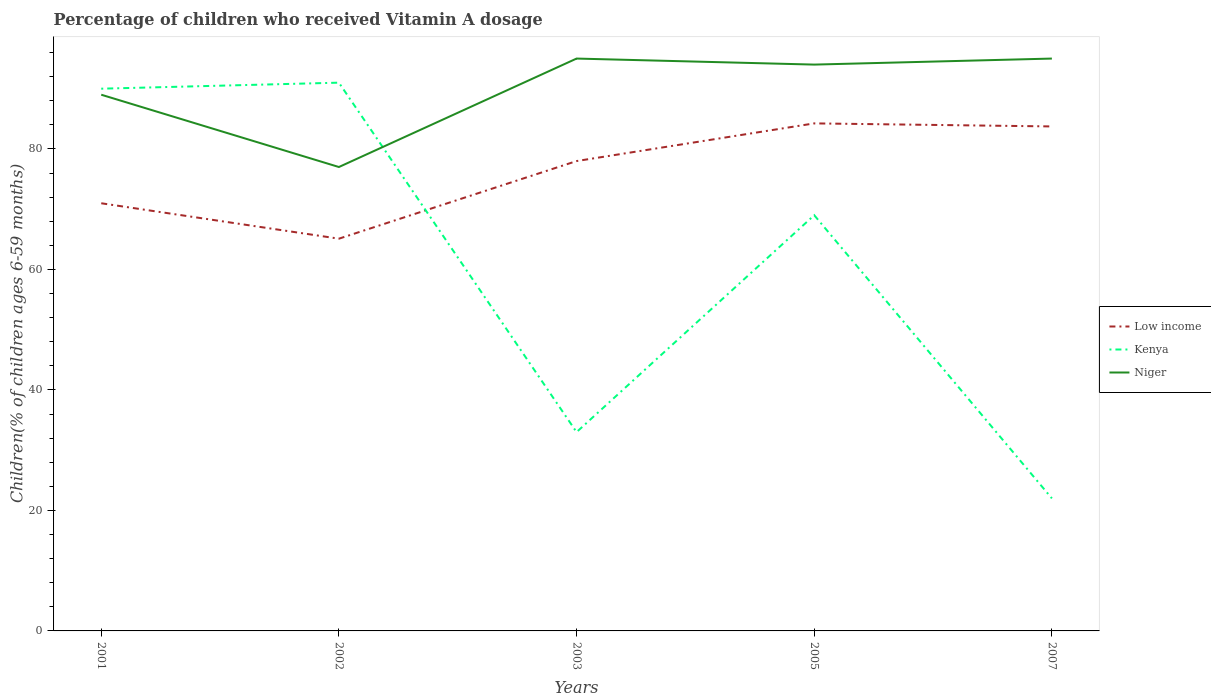Across all years, what is the maximum percentage of children who received Vitamin A dosage in Kenya?
Keep it short and to the point. 22. What is the total percentage of children who received Vitamin A dosage in Niger in the graph?
Your response must be concise. -1. What is the difference between the highest and the second highest percentage of children who received Vitamin A dosage in Niger?
Your answer should be compact. 18. Is the percentage of children who received Vitamin A dosage in Kenya strictly greater than the percentage of children who received Vitamin A dosage in Low income over the years?
Make the answer very short. No. What is the difference between two consecutive major ticks on the Y-axis?
Keep it short and to the point. 20. Does the graph contain any zero values?
Your answer should be very brief. No. Where does the legend appear in the graph?
Your answer should be compact. Center right. How many legend labels are there?
Provide a succinct answer. 3. What is the title of the graph?
Your answer should be compact. Percentage of children who received Vitamin A dosage. What is the label or title of the Y-axis?
Offer a terse response. Children(% of children ages 6-59 months). What is the Children(% of children ages 6-59 months) of Low income in 2001?
Provide a succinct answer. 70.98. What is the Children(% of children ages 6-59 months) of Niger in 2001?
Keep it short and to the point. 89. What is the Children(% of children ages 6-59 months) of Low income in 2002?
Give a very brief answer. 65.1. What is the Children(% of children ages 6-59 months) in Kenya in 2002?
Your answer should be very brief. 91. What is the Children(% of children ages 6-59 months) in Niger in 2002?
Provide a short and direct response. 77. What is the Children(% of children ages 6-59 months) of Low income in 2003?
Provide a succinct answer. 77.99. What is the Children(% of children ages 6-59 months) of Kenya in 2003?
Your response must be concise. 33. What is the Children(% of children ages 6-59 months) in Niger in 2003?
Make the answer very short. 95. What is the Children(% of children ages 6-59 months) in Low income in 2005?
Make the answer very short. 84.24. What is the Children(% of children ages 6-59 months) of Kenya in 2005?
Make the answer very short. 69. What is the Children(% of children ages 6-59 months) of Niger in 2005?
Keep it short and to the point. 94. What is the Children(% of children ages 6-59 months) of Low income in 2007?
Your answer should be compact. 83.73. What is the Children(% of children ages 6-59 months) in Kenya in 2007?
Make the answer very short. 22. What is the Children(% of children ages 6-59 months) of Niger in 2007?
Your response must be concise. 95. Across all years, what is the maximum Children(% of children ages 6-59 months) in Low income?
Provide a succinct answer. 84.24. Across all years, what is the maximum Children(% of children ages 6-59 months) in Kenya?
Your response must be concise. 91. Across all years, what is the maximum Children(% of children ages 6-59 months) in Niger?
Offer a very short reply. 95. Across all years, what is the minimum Children(% of children ages 6-59 months) in Low income?
Your answer should be very brief. 65.1. Across all years, what is the minimum Children(% of children ages 6-59 months) in Kenya?
Keep it short and to the point. 22. What is the total Children(% of children ages 6-59 months) of Low income in the graph?
Your answer should be compact. 382.05. What is the total Children(% of children ages 6-59 months) in Kenya in the graph?
Ensure brevity in your answer.  305. What is the total Children(% of children ages 6-59 months) in Niger in the graph?
Make the answer very short. 450. What is the difference between the Children(% of children ages 6-59 months) of Low income in 2001 and that in 2002?
Offer a very short reply. 5.88. What is the difference between the Children(% of children ages 6-59 months) in Kenya in 2001 and that in 2002?
Provide a short and direct response. -1. What is the difference between the Children(% of children ages 6-59 months) in Low income in 2001 and that in 2003?
Keep it short and to the point. -7. What is the difference between the Children(% of children ages 6-59 months) in Low income in 2001 and that in 2005?
Your answer should be compact. -13.26. What is the difference between the Children(% of children ages 6-59 months) of Niger in 2001 and that in 2005?
Offer a terse response. -5. What is the difference between the Children(% of children ages 6-59 months) of Low income in 2001 and that in 2007?
Offer a very short reply. -12.75. What is the difference between the Children(% of children ages 6-59 months) of Low income in 2002 and that in 2003?
Keep it short and to the point. -12.88. What is the difference between the Children(% of children ages 6-59 months) of Kenya in 2002 and that in 2003?
Offer a very short reply. 58. What is the difference between the Children(% of children ages 6-59 months) of Low income in 2002 and that in 2005?
Ensure brevity in your answer.  -19.14. What is the difference between the Children(% of children ages 6-59 months) of Kenya in 2002 and that in 2005?
Your answer should be compact. 22. What is the difference between the Children(% of children ages 6-59 months) of Niger in 2002 and that in 2005?
Ensure brevity in your answer.  -17. What is the difference between the Children(% of children ages 6-59 months) of Low income in 2002 and that in 2007?
Make the answer very short. -18.63. What is the difference between the Children(% of children ages 6-59 months) of Kenya in 2002 and that in 2007?
Keep it short and to the point. 69. What is the difference between the Children(% of children ages 6-59 months) of Niger in 2002 and that in 2007?
Give a very brief answer. -18. What is the difference between the Children(% of children ages 6-59 months) in Low income in 2003 and that in 2005?
Keep it short and to the point. -6.25. What is the difference between the Children(% of children ages 6-59 months) in Kenya in 2003 and that in 2005?
Provide a short and direct response. -36. What is the difference between the Children(% of children ages 6-59 months) of Low income in 2003 and that in 2007?
Your answer should be compact. -5.75. What is the difference between the Children(% of children ages 6-59 months) of Niger in 2003 and that in 2007?
Make the answer very short. 0. What is the difference between the Children(% of children ages 6-59 months) of Low income in 2005 and that in 2007?
Give a very brief answer. 0.51. What is the difference between the Children(% of children ages 6-59 months) in Kenya in 2005 and that in 2007?
Provide a short and direct response. 47. What is the difference between the Children(% of children ages 6-59 months) of Low income in 2001 and the Children(% of children ages 6-59 months) of Kenya in 2002?
Offer a terse response. -20.02. What is the difference between the Children(% of children ages 6-59 months) of Low income in 2001 and the Children(% of children ages 6-59 months) of Niger in 2002?
Offer a terse response. -6.02. What is the difference between the Children(% of children ages 6-59 months) in Low income in 2001 and the Children(% of children ages 6-59 months) in Kenya in 2003?
Your response must be concise. 37.98. What is the difference between the Children(% of children ages 6-59 months) in Low income in 2001 and the Children(% of children ages 6-59 months) in Niger in 2003?
Your response must be concise. -24.02. What is the difference between the Children(% of children ages 6-59 months) of Kenya in 2001 and the Children(% of children ages 6-59 months) of Niger in 2003?
Offer a very short reply. -5. What is the difference between the Children(% of children ages 6-59 months) of Low income in 2001 and the Children(% of children ages 6-59 months) of Kenya in 2005?
Offer a very short reply. 1.98. What is the difference between the Children(% of children ages 6-59 months) in Low income in 2001 and the Children(% of children ages 6-59 months) in Niger in 2005?
Offer a very short reply. -23.02. What is the difference between the Children(% of children ages 6-59 months) of Kenya in 2001 and the Children(% of children ages 6-59 months) of Niger in 2005?
Make the answer very short. -4. What is the difference between the Children(% of children ages 6-59 months) in Low income in 2001 and the Children(% of children ages 6-59 months) in Kenya in 2007?
Provide a succinct answer. 48.98. What is the difference between the Children(% of children ages 6-59 months) in Low income in 2001 and the Children(% of children ages 6-59 months) in Niger in 2007?
Offer a terse response. -24.02. What is the difference between the Children(% of children ages 6-59 months) in Kenya in 2001 and the Children(% of children ages 6-59 months) in Niger in 2007?
Make the answer very short. -5. What is the difference between the Children(% of children ages 6-59 months) of Low income in 2002 and the Children(% of children ages 6-59 months) of Kenya in 2003?
Your answer should be compact. 32.1. What is the difference between the Children(% of children ages 6-59 months) of Low income in 2002 and the Children(% of children ages 6-59 months) of Niger in 2003?
Offer a terse response. -29.9. What is the difference between the Children(% of children ages 6-59 months) in Kenya in 2002 and the Children(% of children ages 6-59 months) in Niger in 2003?
Offer a very short reply. -4. What is the difference between the Children(% of children ages 6-59 months) of Low income in 2002 and the Children(% of children ages 6-59 months) of Kenya in 2005?
Your answer should be compact. -3.9. What is the difference between the Children(% of children ages 6-59 months) of Low income in 2002 and the Children(% of children ages 6-59 months) of Niger in 2005?
Your response must be concise. -28.9. What is the difference between the Children(% of children ages 6-59 months) of Low income in 2002 and the Children(% of children ages 6-59 months) of Kenya in 2007?
Provide a succinct answer. 43.1. What is the difference between the Children(% of children ages 6-59 months) of Low income in 2002 and the Children(% of children ages 6-59 months) of Niger in 2007?
Provide a short and direct response. -29.9. What is the difference between the Children(% of children ages 6-59 months) in Kenya in 2002 and the Children(% of children ages 6-59 months) in Niger in 2007?
Make the answer very short. -4. What is the difference between the Children(% of children ages 6-59 months) of Low income in 2003 and the Children(% of children ages 6-59 months) of Kenya in 2005?
Offer a very short reply. 8.99. What is the difference between the Children(% of children ages 6-59 months) in Low income in 2003 and the Children(% of children ages 6-59 months) in Niger in 2005?
Make the answer very short. -16.01. What is the difference between the Children(% of children ages 6-59 months) of Kenya in 2003 and the Children(% of children ages 6-59 months) of Niger in 2005?
Provide a short and direct response. -61. What is the difference between the Children(% of children ages 6-59 months) in Low income in 2003 and the Children(% of children ages 6-59 months) in Kenya in 2007?
Make the answer very short. 55.99. What is the difference between the Children(% of children ages 6-59 months) of Low income in 2003 and the Children(% of children ages 6-59 months) of Niger in 2007?
Ensure brevity in your answer.  -17.01. What is the difference between the Children(% of children ages 6-59 months) of Kenya in 2003 and the Children(% of children ages 6-59 months) of Niger in 2007?
Provide a succinct answer. -62. What is the difference between the Children(% of children ages 6-59 months) in Low income in 2005 and the Children(% of children ages 6-59 months) in Kenya in 2007?
Your answer should be compact. 62.24. What is the difference between the Children(% of children ages 6-59 months) in Low income in 2005 and the Children(% of children ages 6-59 months) in Niger in 2007?
Ensure brevity in your answer.  -10.76. What is the difference between the Children(% of children ages 6-59 months) of Kenya in 2005 and the Children(% of children ages 6-59 months) of Niger in 2007?
Offer a very short reply. -26. What is the average Children(% of children ages 6-59 months) in Low income per year?
Offer a very short reply. 76.41. What is the average Children(% of children ages 6-59 months) of Kenya per year?
Offer a very short reply. 61. In the year 2001, what is the difference between the Children(% of children ages 6-59 months) of Low income and Children(% of children ages 6-59 months) of Kenya?
Your answer should be compact. -19.02. In the year 2001, what is the difference between the Children(% of children ages 6-59 months) in Low income and Children(% of children ages 6-59 months) in Niger?
Offer a terse response. -18.02. In the year 2002, what is the difference between the Children(% of children ages 6-59 months) in Low income and Children(% of children ages 6-59 months) in Kenya?
Ensure brevity in your answer.  -25.9. In the year 2002, what is the difference between the Children(% of children ages 6-59 months) of Low income and Children(% of children ages 6-59 months) of Niger?
Your answer should be compact. -11.9. In the year 2002, what is the difference between the Children(% of children ages 6-59 months) of Kenya and Children(% of children ages 6-59 months) of Niger?
Your response must be concise. 14. In the year 2003, what is the difference between the Children(% of children ages 6-59 months) in Low income and Children(% of children ages 6-59 months) in Kenya?
Keep it short and to the point. 44.99. In the year 2003, what is the difference between the Children(% of children ages 6-59 months) in Low income and Children(% of children ages 6-59 months) in Niger?
Offer a very short reply. -17.01. In the year 2003, what is the difference between the Children(% of children ages 6-59 months) in Kenya and Children(% of children ages 6-59 months) in Niger?
Ensure brevity in your answer.  -62. In the year 2005, what is the difference between the Children(% of children ages 6-59 months) in Low income and Children(% of children ages 6-59 months) in Kenya?
Offer a terse response. 15.24. In the year 2005, what is the difference between the Children(% of children ages 6-59 months) of Low income and Children(% of children ages 6-59 months) of Niger?
Your response must be concise. -9.76. In the year 2007, what is the difference between the Children(% of children ages 6-59 months) in Low income and Children(% of children ages 6-59 months) in Kenya?
Provide a succinct answer. 61.73. In the year 2007, what is the difference between the Children(% of children ages 6-59 months) of Low income and Children(% of children ages 6-59 months) of Niger?
Ensure brevity in your answer.  -11.27. In the year 2007, what is the difference between the Children(% of children ages 6-59 months) in Kenya and Children(% of children ages 6-59 months) in Niger?
Offer a terse response. -73. What is the ratio of the Children(% of children ages 6-59 months) of Low income in 2001 to that in 2002?
Keep it short and to the point. 1.09. What is the ratio of the Children(% of children ages 6-59 months) in Kenya in 2001 to that in 2002?
Keep it short and to the point. 0.99. What is the ratio of the Children(% of children ages 6-59 months) of Niger in 2001 to that in 2002?
Provide a succinct answer. 1.16. What is the ratio of the Children(% of children ages 6-59 months) in Low income in 2001 to that in 2003?
Give a very brief answer. 0.91. What is the ratio of the Children(% of children ages 6-59 months) in Kenya in 2001 to that in 2003?
Provide a short and direct response. 2.73. What is the ratio of the Children(% of children ages 6-59 months) of Niger in 2001 to that in 2003?
Offer a very short reply. 0.94. What is the ratio of the Children(% of children ages 6-59 months) of Low income in 2001 to that in 2005?
Ensure brevity in your answer.  0.84. What is the ratio of the Children(% of children ages 6-59 months) in Kenya in 2001 to that in 2005?
Your answer should be compact. 1.3. What is the ratio of the Children(% of children ages 6-59 months) in Niger in 2001 to that in 2005?
Give a very brief answer. 0.95. What is the ratio of the Children(% of children ages 6-59 months) in Low income in 2001 to that in 2007?
Provide a short and direct response. 0.85. What is the ratio of the Children(% of children ages 6-59 months) in Kenya in 2001 to that in 2007?
Make the answer very short. 4.09. What is the ratio of the Children(% of children ages 6-59 months) in Niger in 2001 to that in 2007?
Give a very brief answer. 0.94. What is the ratio of the Children(% of children ages 6-59 months) of Low income in 2002 to that in 2003?
Offer a terse response. 0.83. What is the ratio of the Children(% of children ages 6-59 months) in Kenya in 2002 to that in 2003?
Your answer should be compact. 2.76. What is the ratio of the Children(% of children ages 6-59 months) of Niger in 2002 to that in 2003?
Offer a very short reply. 0.81. What is the ratio of the Children(% of children ages 6-59 months) of Low income in 2002 to that in 2005?
Make the answer very short. 0.77. What is the ratio of the Children(% of children ages 6-59 months) in Kenya in 2002 to that in 2005?
Ensure brevity in your answer.  1.32. What is the ratio of the Children(% of children ages 6-59 months) of Niger in 2002 to that in 2005?
Your answer should be very brief. 0.82. What is the ratio of the Children(% of children ages 6-59 months) of Low income in 2002 to that in 2007?
Give a very brief answer. 0.78. What is the ratio of the Children(% of children ages 6-59 months) of Kenya in 2002 to that in 2007?
Provide a short and direct response. 4.14. What is the ratio of the Children(% of children ages 6-59 months) in Niger in 2002 to that in 2007?
Your response must be concise. 0.81. What is the ratio of the Children(% of children ages 6-59 months) of Low income in 2003 to that in 2005?
Offer a terse response. 0.93. What is the ratio of the Children(% of children ages 6-59 months) of Kenya in 2003 to that in 2005?
Give a very brief answer. 0.48. What is the ratio of the Children(% of children ages 6-59 months) of Niger in 2003 to that in 2005?
Offer a terse response. 1.01. What is the ratio of the Children(% of children ages 6-59 months) of Low income in 2003 to that in 2007?
Ensure brevity in your answer.  0.93. What is the ratio of the Children(% of children ages 6-59 months) in Niger in 2003 to that in 2007?
Your answer should be compact. 1. What is the ratio of the Children(% of children ages 6-59 months) of Kenya in 2005 to that in 2007?
Your answer should be very brief. 3.14. What is the ratio of the Children(% of children ages 6-59 months) in Niger in 2005 to that in 2007?
Provide a short and direct response. 0.99. What is the difference between the highest and the second highest Children(% of children ages 6-59 months) of Low income?
Ensure brevity in your answer.  0.51. What is the difference between the highest and the second highest Children(% of children ages 6-59 months) of Kenya?
Your response must be concise. 1. What is the difference between the highest and the lowest Children(% of children ages 6-59 months) in Low income?
Make the answer very short. 19.14. What is the difference between the highest and the lowest Children(% of children ages 6-59 months) of Niger?
Offer a terse response. 18. 